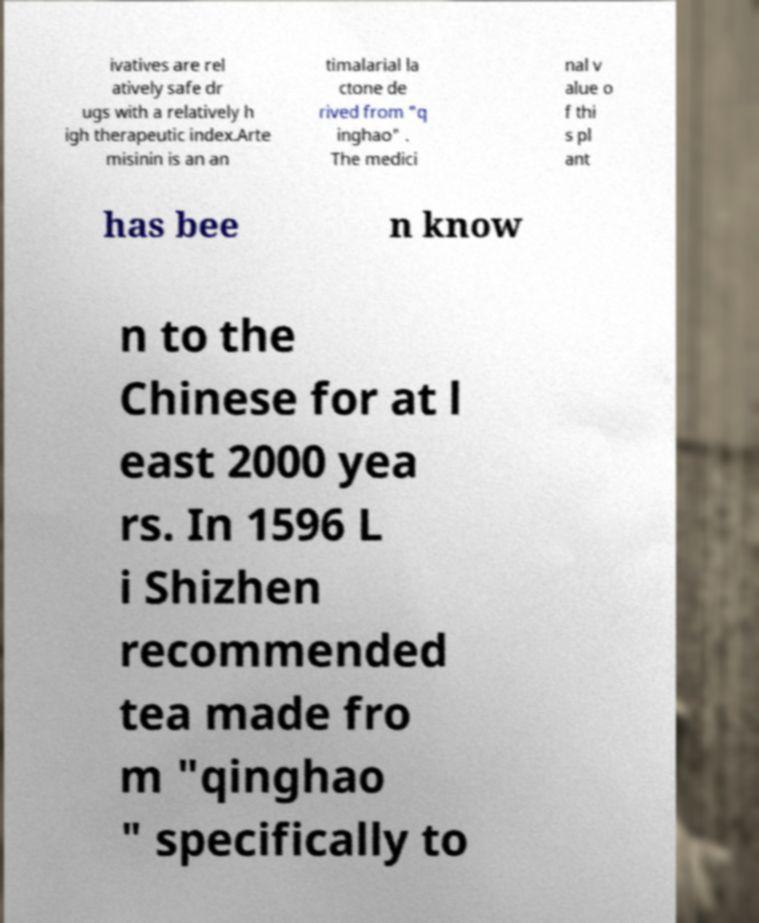Can you read and provide the text displayed in the image?This photo seems to have some interesting text. Can you extract and type it out for me? ivatives are rel atively safe dr ugs with a relatively h igh therapeutic index.Arte misinin is an an timalarial la ctone de rived from "q inghao" . The medici nal v alue o f thi s pl ant has bee n know n to the Chinese for at l east 2000 yea rs. In 1596 L i Shizhen recommended tea made fro m "qinghao " specifically to 